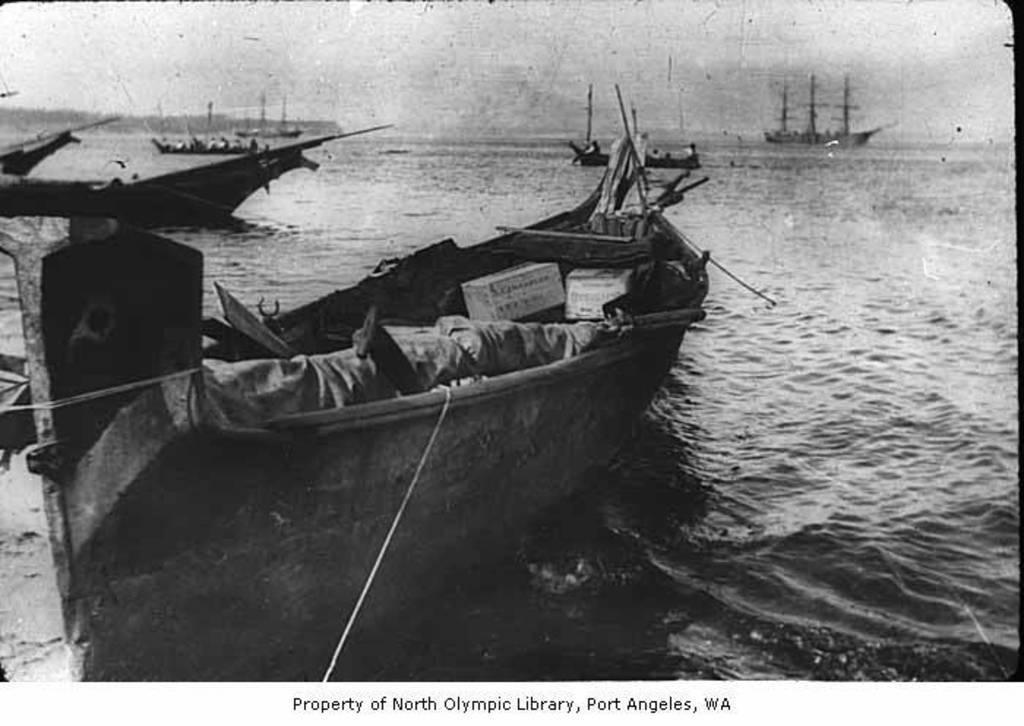How would you summarize this image in a sentence or two? It is a black and white image. In this image we can see the boats on the surface of the river. We can also see the sky and at the bottom we can see the text. 